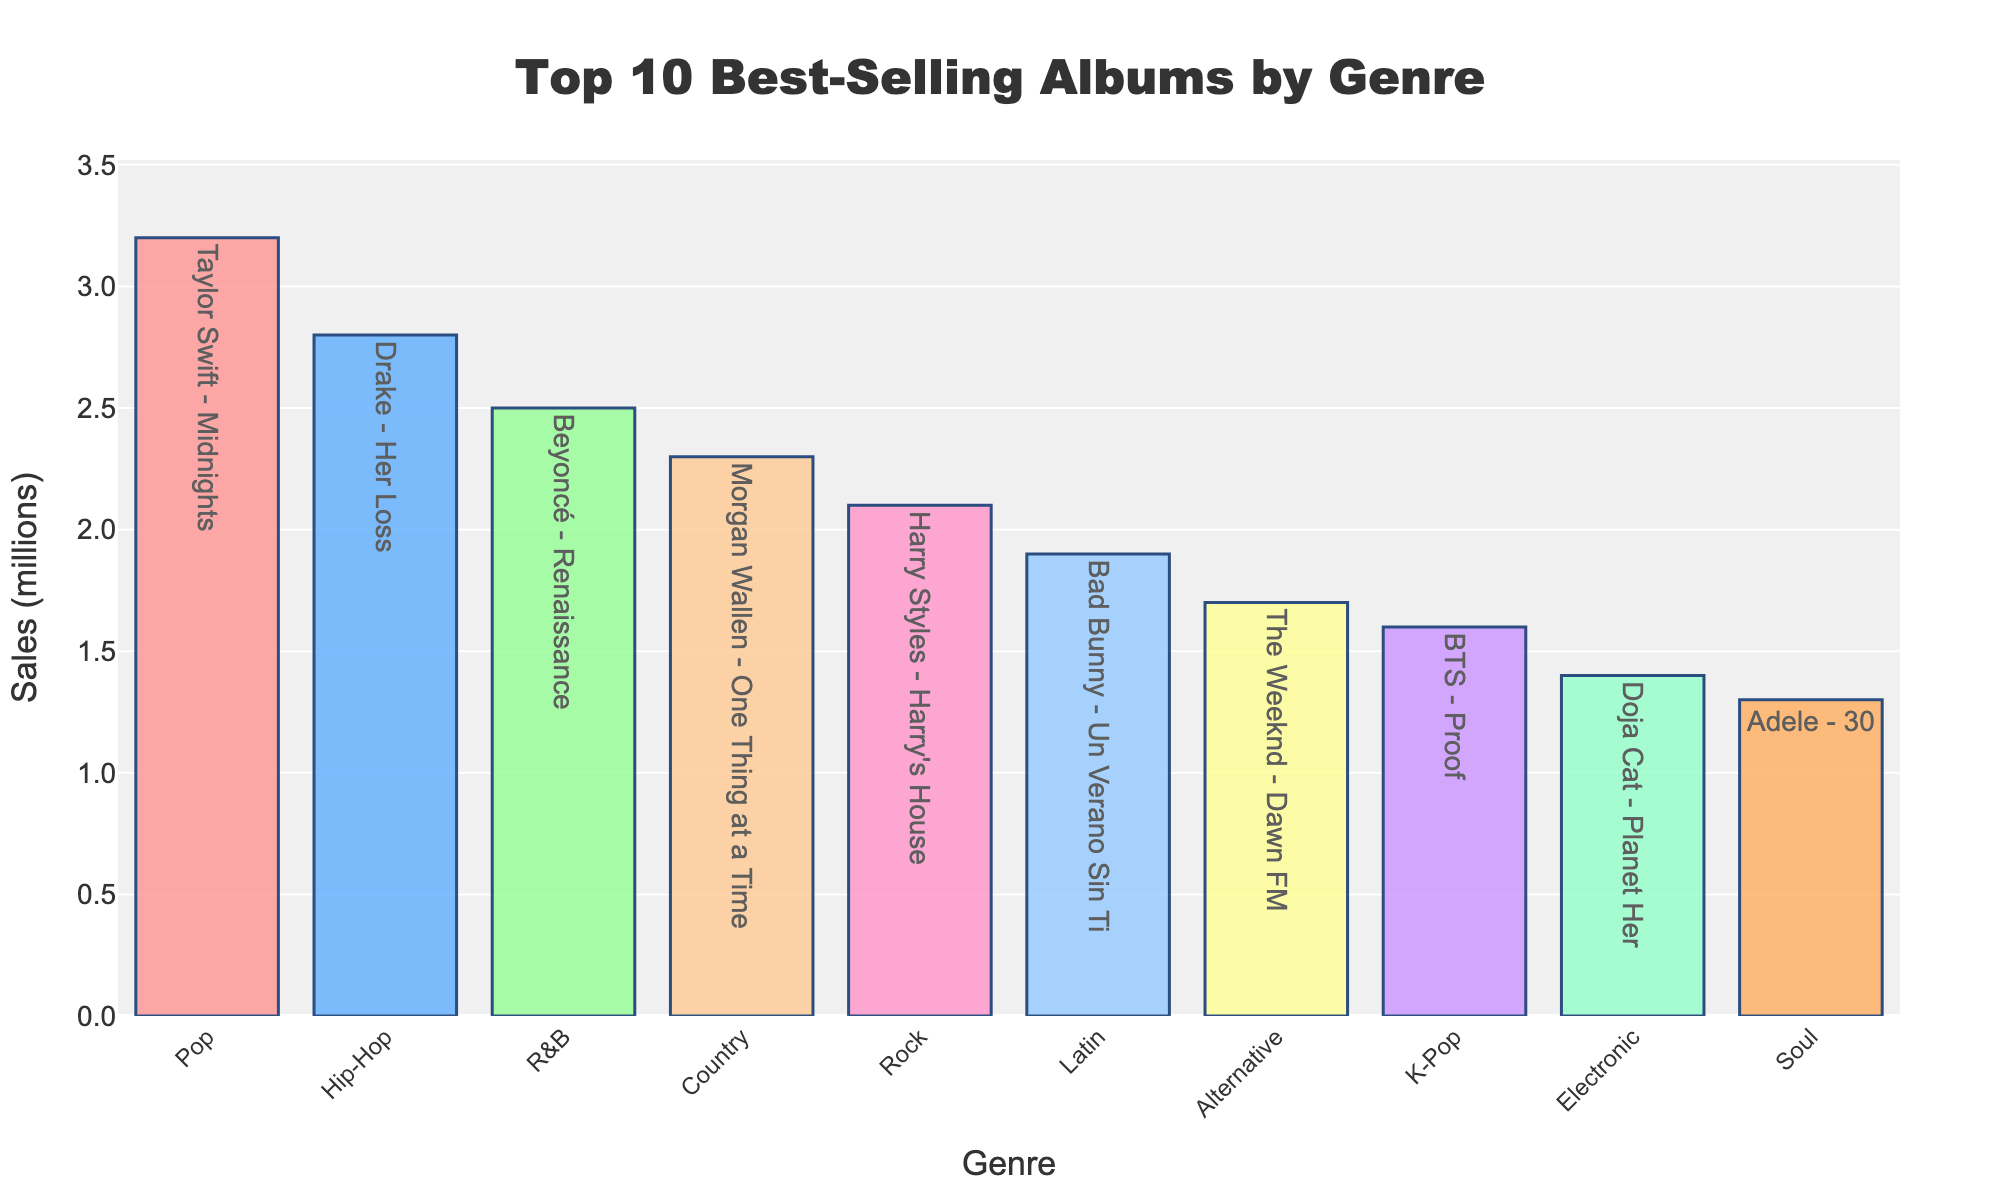which genre has the highest album sales? The bar representing Pop is the tallest, indicating that it has the highest sales. The hover text confirms "Taylor Swift - Midnights" with 3.2 million sales.
Answer: Pop which genre has lower album sales: Alternative or Electronic? To find out which genre has lower album sales, we can compare the heights of the bars for Alternative and Electronic. The bar for Electronic is shorter than that for Alternative. The hover text shows that "Doja Cat - Planet Her" has 1.4 million sales, while "The Weeknd - Dawn FM" has 1.7 million sales.
Answer: Electronic What is the total sales of the top 5 albums? Sum the sales of the top 5 albums: 3.2 (Pop) + 2.8 (Hip-Hop) + 2.5 (R&B) + 2.3 (Country) + 2.1 (Rock) = 12.9 million.
Answer: 12.9 million How many genres have album sales greater than 2 million? Count the bars that exceed the 2 million mark on the y-axis. There are five: Pop, Hip-Hop, R&B, Country, and Rock.
Answer: 5 Which genre has nearly the same sales as Country? Look for bars of similar height to the Country bar (2.3 million). The Rock bar has sales close to this value at 2.1 million.
Answer: Rock What is the average sales of all the albums? Sum all the album sales and then divide by the number of albums. The total is 3.2 + 2.8 + 2.5 + 2.3 + 2.1 + 1.9 + 1.7 + 1.6 + 1.4 + 1.3 = 22.8. Dividing by 10 albums gives an average of 22.8 / 10 = 2.28 million.
Answer: 2.28 million Which album has more sales: "Proof" by BTS or "Planet Her" by Doja Cat? Compare the heights of the bars for K-Pop and Electronic. The hover text shows "BTS - Proof" has 1.6 million sales, while "Doja Cat - Planet Her" has 1.4 million sales, indicating that BTS has more sales.
Answer: Proof by BTS What is the difference in sales between the genres with the highest and lowest sales? Subtract the lowest sales (Soul with 1.3 million) from the highest sales (Pop with 3.2 million). The difference is 3.2 - 1.3 = 1.9 million.
Answer: 1.9 million Which genre's album sales are closest to the average album sales? First calculate the average sales (2.28 million). Check the bars' sales near this value. Country (2.3 million) and Rock (2.1 million) are both close, with Country being slightly closer.
Answer: Country 